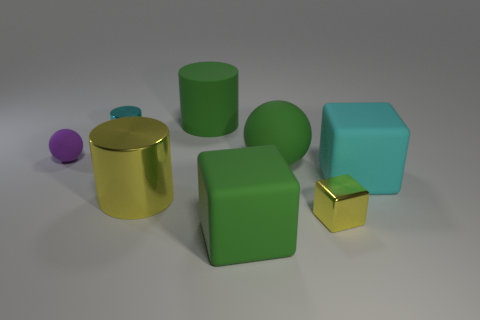There is a shiny cube; is its color the same as the big matte object that is behind the tiny cyan cylinder?
Keep it short and to the point. No. What is the shape of the tiny object that is the same material as the small cylinder?
Provide a short and direct response. Cube. Do the yellow shiny thing that is to the left of the green cube and the cyan rubber thing have the same shape?
Provide a succinct answer. No. There is a yellow thing right of the rubber object behind the tiny purple matte thing; how big is it?
Your answer should be very brief. Small. There is a large thing that is made of the same material as the yellow block; what color is it?
Your response must be concise. Yellow. How many rubber cubes have the same size as the yellow cylinder?
Your answer should be very brief. 2. What number of purple objects are large rubber cylinders or rubber spheres?
Give a very brief answer. 1. How many objects are large metallic cylinders or tiny purple objects that are left of the big metallic cylinder?
Ensure brevity in your answer.  2. What is the material of the cylinder in front of the large green sphere?
Provide a short and direct response. Metal. There is a metallic object that is the same size as the yellow block; what shape is it?
Offer a very short reply. Cylinder. 